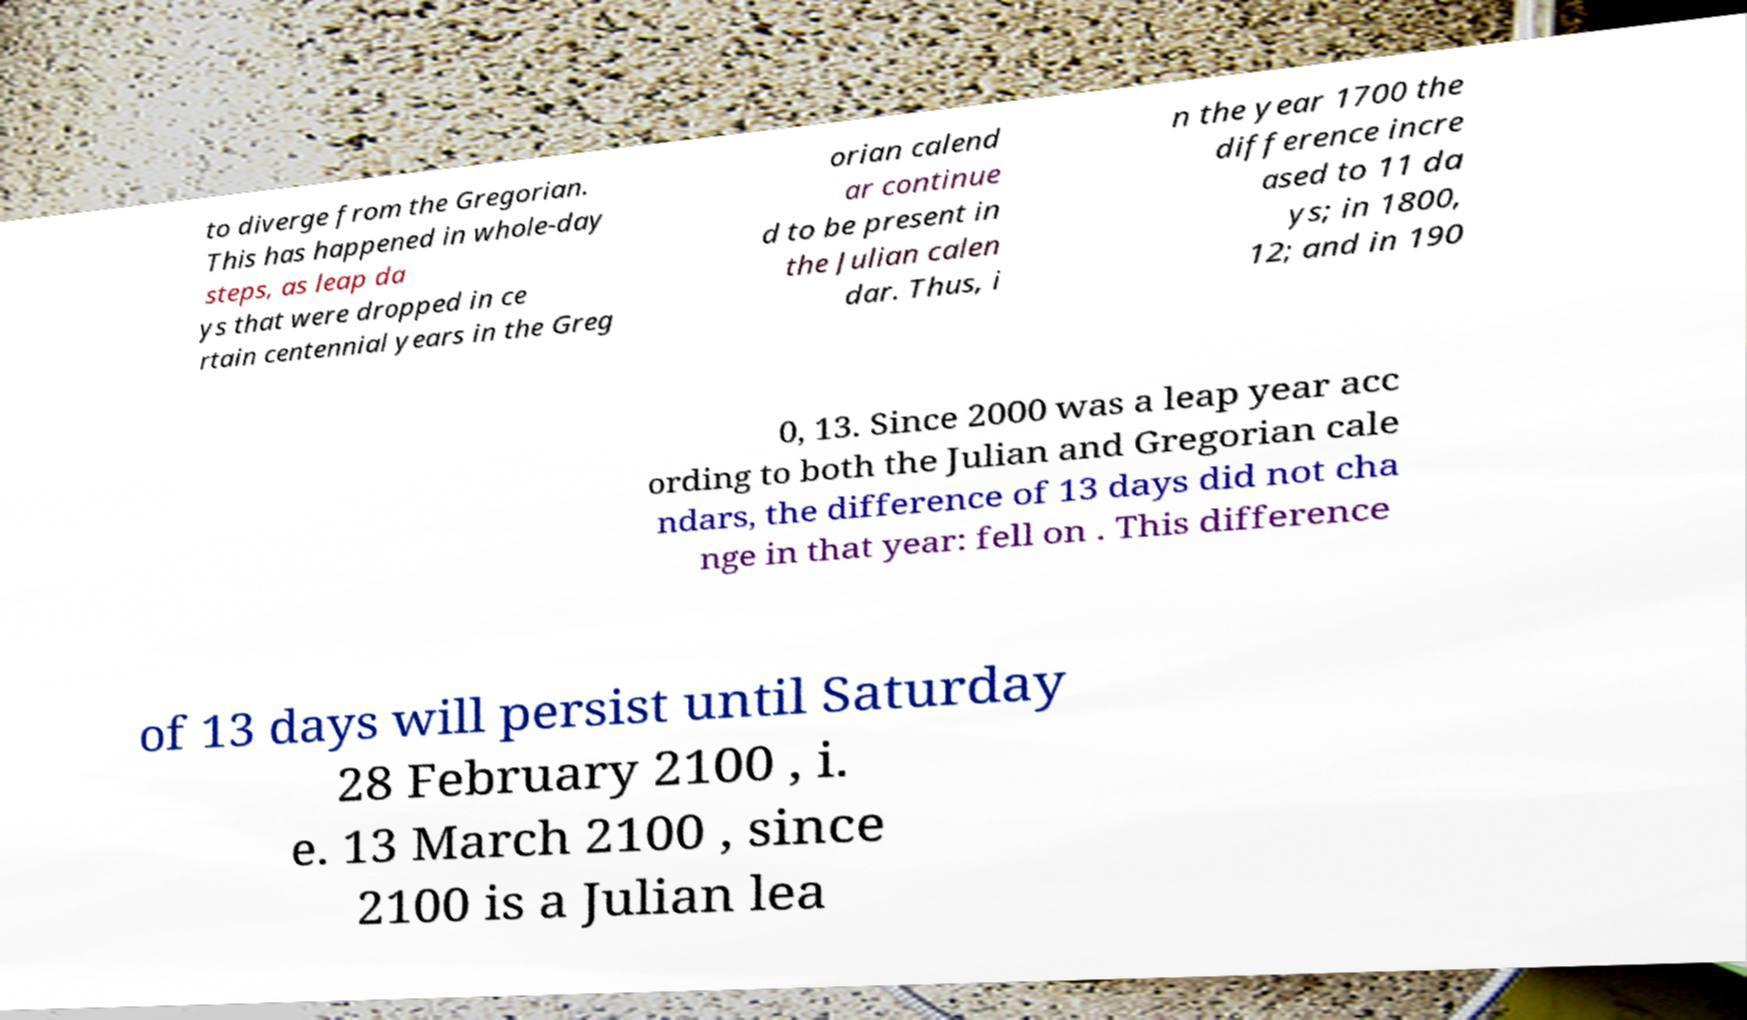Please read and relay the text visible in this image. What does it say? to diverge from the Gregorian. This has happened in whole-day steps, as leap da ys that were dropped in ce rtain centennial years in the Greg orian calend ar continue d to be present in the Julian calen dar. Thus, i n the year 1700 the difference incre ased to 11 da ys; in 1800, 12; and in 190 0, 13. Since 2000 was a leap year acc ording to both the Julian and Gregorian cale ndars, the difference of 13 days did not cha nge in that year: fell on . This difference of 13 days will persist until Saturday 28 February 2100 , i. e. 13 March 2100 , since 2100 is a Julian lea 